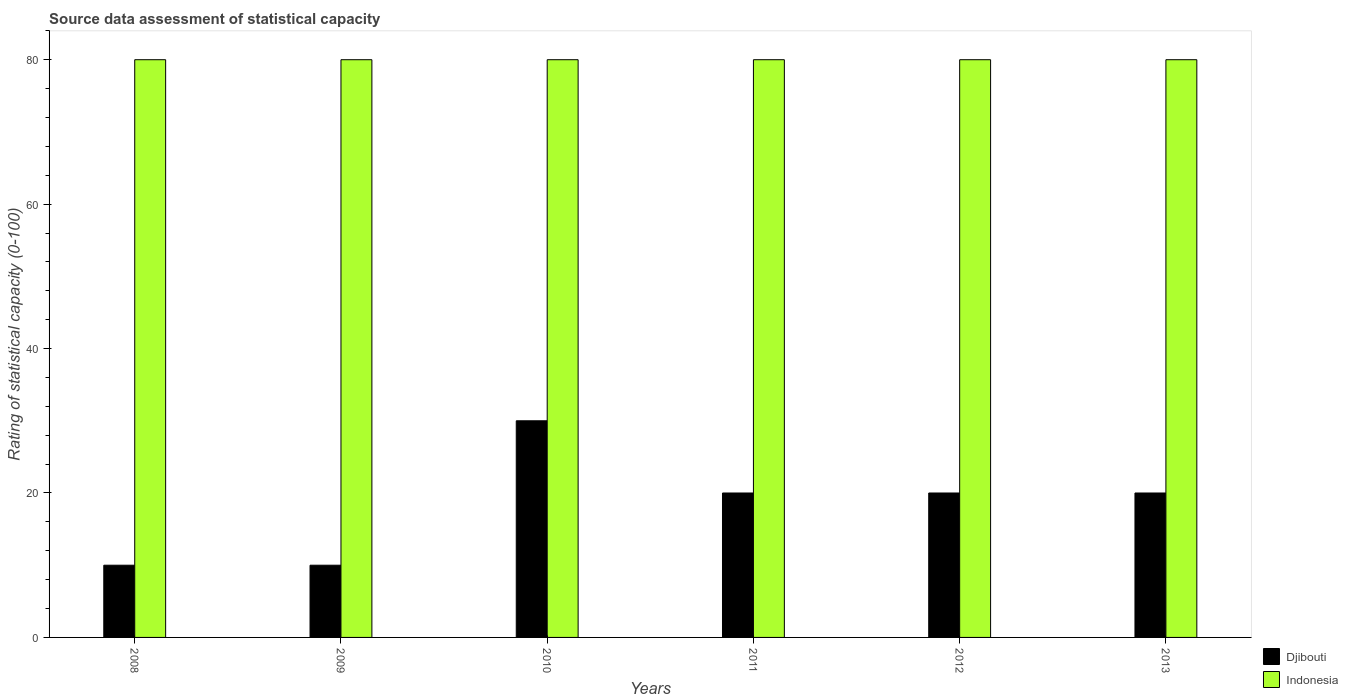How many groups of bars are there?
Ensure brevity in your answer.  6. Are the number of bars on each tick of the X-axis equal?
Make the answer very short. Yes. How many bars are there on the 3rd tick from the right?
Offer a terse response. 2. In how many cases, is the number of bars for a given year not equal to the number of legend labels?
Your response must be concise. 0. What is the rating of statistical capacity in Djibouti in 2011?
Offer a very short reply. 20. Across all years, what is the minimum rating of statistical capacity in Djibouti?
Keep it short and to the point. 10. In which year was the rating of statistical capacity in Djibouti minimum?
Keep it short and to the point. 2008. What is the total rating of statistical capacity in Djibouti in the graph?
Your answer should be very brief. 110. What is the difference between the rating of statistical capacity in Indonesia in 2008 and that in 2009?
Offer a terse response. 0. What is the average rating of statistical capacity in Djibouti per year?
Provide a succinct answer. 18.33. In the year 2013, what is the difference between the rating of statistical capacity in Indonesia and rating of statistical capacity in Djibouti?
Provide a succinct answer. 60. What is the ratio of the rating of statistical capacity in Djibouti in 2010 to that in 2011?
Your response must be concise. 1.5. Is the rating of statistical capacity in Indonesia in 2008 less than that in 2013?
Offer a terse response. No. What is the difference between the highest and the second highest rating of statistical capacity in Djibouti?
Your answer should be very brief. 10. In how many years, is the rating of statistical capacity in Indonesia greater than the average rating of statistical capacity in Indonesia taken over all years?
Provide a short and direct response. 0. Is the sum of the rating of statistical capacity in Indonesia in 2010 and 2013 greater than the maximum rating of statistical capacity in Djibouti across all years?
Offer a terse response. Yes. What does the 1st bar from the left in 2011 represents?
Make the answer very short. Djibouti. What does the 2nd bar from the right in 2011 represents?
Your answer should be compact. Djibouti. How many bars are there?
Your answer should be compact. 12. Are all the bars in the graph horizontal?
Offer a terse response. No. How many years are there in the graph?
Make the answer very short. 6. What is the difference between two consecutive major ticks on the Y-axis?
Make the answer very short. 20. Does the graph contain any zero values?
Offer a terse response. No. Does the graph contain grids?
Ensure brevity in your answer.  No. How are the legend labels stacked?
Provide a succinct answer. Vertical. What is the title of the graph?
Your response must be concise. Source data assessment of statistical capacity. Does "Bangladesh" appear as one of the legend labels in the graph?
Your answer should be very brief. No. What is the label or title of the X-axis?
Your response must be concise. Years. What is the label or title of the Y-axis?
Your response must be concise. Rating of statistical capacity (0-100). What is the Rating of statistical capacity (0-100) of Indonesia in 2010?
Offer a very short reply. 80. What is the Rating of statistical capacity (0-100) of Djibouti in 2011?
Ensure brevity in your answer.  20. What is the Rating of statistical capacity (0-100) of Djibouti in 2012?
Your answer should be very brief. 20. What is the Rating of statistical capacity (0-100) of Indonesia in 2012?
Ensure brevity in your answer.  80. Across all years, what is the minimum Rating of statistical capacity (0-100) in Djibouti?
Keep it short and to the point. 10. Across all years, what is the minimum Rating of statistical capacity (0-100) in Indonesia?
Your answer should be compact. 80. What is the total Rating of statistical capacity (0-100) of Djibouti in the graph?
Provide a succinct answer. 110. What is the total Rating of statistical capacity (0-100) in Indonesia in the graph?
Provide a succinct answer. 480. What is the difference between the Rating of statistical capacity (0-100) in Indonesia in 2008 and that in 2010?
Your answer should be compact. 0. What is the difference between the Rating of statistical capacity (0-100) in Djibouti in 2008 and that in 2011?
Make the answer very short. -10. What is the difference between the Rating of statistical capacity (0-100) in Indonesia in 2008 and that in 2011?
Give a very brief answer. 0. What is the difference between the Rating of statistical capacity (0-100) of Djibouti in 2008 and that in 2012?
Offer a terse response. -10. What is the difference between the Rating of statistical capacity (0-100) of Djibouti in 2008 and that in 2013?
Give a very brief answer. -10. What is the difference between the Rating of statistical capacity (0-100) in Indonesia in 2008 and that in 2013?
Provide a succinct answer. 0. What is the difference between the Rating of statistical capacity (0-100) of Djibouti in 2009 and that in 2010?
Your answer should be very brief. -20. What is the difference between the Rating of statistical capacity (0-100) of Indonesia in 2009 and that in 2010?
Your answer should be very brief. 0. What is the difference between the Rating of statistical capacity (0-100) in Djibouti in 2009 and that in 2011?
Make the answer very short. -10. What is the difference between the Rating of statistical capacity (0-100) of Indonesia in 2009 and that in 2012?
Your response must be concise. 0. What is the difference between the Rating of statistical capacity (0-100) of Djibouti in 2010 and that in 2012?
Your response must be concise. 10. What is the difference between the Rating of statistical capacity (0-100) in Indonesia in 2010 and that in 2012?
Make the answer very short. 0. What is the difference between the Rating of statistical capacity (0-100) in Indonesia in 2010 and that in 2013?
Your answer should be compact. 0. What is the difference between the Rating of statistical capacity (0-100) of Indonesia in 2011 and that in 2012?
Provide a short and direct response. 0. What is the difference between the Rating of statistical capacity (0-100) of Djibouti in 2011 and that in 2013?
Offer a terse response. 0. What is the difference between the Rating of statistical capacity (0-100) in Indonesia in 2011 and that in 2013?
Give a very brief answer. 0. What is the difference between the Rating of statistical capacity (0-100) of Djibouti in 2008 and the Rating of statistical capacity (0-100) of Indonesia in 2009?
Give a very brief answer. -70. What is the difference between the Rating of statistical capacity (0-100) of Djibouti in 2008 and the Rating of statistical capacity (0-100) of Indonesia in 2010?
Provide a succinct answer. -70. What is the difference between the Rating of statistical capacity (0-100) in Djibouti in 2008 and the Rating of statistical capacity (0-100) in Indonesia in 2011?
Your answer should be compact. -70. What is the difference between the Rating of statistical capacity (0-100) of Djibouti in 2008 and the Rating of statistical capacity (0-100) of Indonesia in 2012?
Provide a succinct answer. -70. What is the difference between the Rating of statistical capacity (0-100) of Djibouti in 2008 and the Rating of statistical capacity (0-100) of Indonesia in 2013?
Offer a terse response. -70. What is the difference between the Rating of statistical capacity (0-100) in Djibouti in 2009 and the Rating of statistical capacity (0-100) in Indonesia in 2010?
Make the answer very short. -70. What is the difference between the Rating of statistical capacity (0-100) of Djibouti in 2009 and the Rating of statistical capacity (0-100) of Indonesia in 2011?
Offer a very short reply. -70. What is the difference between the Rating of statistical capacity (0-100) in Djibouti in 2009 and the Rating of statistical capacity (0-100) in Indonesia in 2012?
Give a very brief answer. -70. What is the difference between the Rating of statistical capacity (0-100) in Djibouti in 2009 and the Rating of statistical capacity (0-100) in Indonesia in 2013?
Your answer should be compact. -70. What is the difference between the Rating of statistical capacity (0-100) of Djibouti in 2011 and the Rating of statistical capacity (0-100) of Indonesia in 2012?
Provide a succinct answer. -60. What is the difference between the Rating of statistical capacity (0-100) in Djibouti in 2011 and the Rating of statistical capacity (0-100) in Indonesia in 2013?
Provide a short and direct response. -60. What is the difference between the Rating of statistical capacity (0-100) of Djibouti in 2012 and the Rating of statistical capacity (0-100) of Indonesia in 2013?
Give a very brief answer. -60. What is the average Rating of statistical capacity (0-100) in Djibouti per year?
Provide a succinct answer. 18.33. What is the average Rating of statistical capacity (0-100) of Indonesia per year?
Your answer should be very brief. 80. In the year 2008, what is the difference between the Rating of statistical capacity (0-100) in Djibouti and Rating of statistical capacity (0-100) in Indonesia?
Keep it short and to the point. -70. In the year 2009, what is the difference between the Rating of statistical capacity (0-100) in Djibouti and Rating of statistical capacity (0-100) in Indonesia?
Provide a succinct answer. -70. In the year 2011, what is the difference between the Rating of statistical capacity (0-100) in Djibouti and Rating of statistical capacity (0-100) in Indonesia?
Provide a succinct answer. -60. In the year 2012, what is the difference between the Rating of statistical capacity (0-100) in Djibouti and Rating of statistical capacity (0-100) in Indonesia?
Provide a succinct answer. -60. In the year 2013, what is the difference between the Rating of statistical capacity (0-100) of Djibouti and Rating of statistical capacity (0-100) of Indonesia?
Make the answer very short. -60. What is the ratio of the Rating of statistical capacity (0-100) in Indonesia in 2008 to that in 2009?
Ensure brevity in your answer.  1. What is the ratio of the Rating of statistical capacity (0-100) in Indonesia in 2008 to that in 2010?
Offer a very short reply. 1. What is the ratio of the Rating of statistical capacity (0-100) in Djibouti in 2008 to that in 2011?
Give a very brief answer. 0.5. What is the ratio of the Rating of statistical capacity (0-100) of Djibouti in 2008 to that in 2012?
Ensure brevity in your answer.  0.5. What is the ratio of the Rating of statistical capacity (0-100) in Indonesia in 2009 to that in 2010?
Provide a succinct answer. 1. What is the ratio of the Rating of statistical capacity (0-100) of Djibouti in 2009 to that in 2011?
Offer a terse response. 0.5. What is the ratio of the Rating of statistical capacity (0-100) of Indonesia in 2009 to that in 2011?
Make the answer very short. 1. What is the ratio of the Rating of statistical capacity (0-100) in Djibouti in 2009 to that in 2012?
Give a very brief answer. 0.5. What is the ratio of the Rating of statistical capacity (0-100) of Djibouti in 2009 to that in 2013?
Offer a very short reply. 0.5. What is the ratio of the Rating of statistical capacity (0-100) in Indonesia in 2009 to that in 2013?
Give a very brief answer. 1. What is the ratio of the Rating of statistical capacity (0-100) of Djibouti in 2010 to that in 2013?
Provide a succinct answer. 1.5. What is the ratio of the Rating of statistical capacity (0-100) of Indonesia in 2012 to that in 2013?
Your response must be concise. 1. What is the difference between the highest and the second highest Rating of statistical capacity (0-100) of Djibouti?
Keep it short and to the point. 10. 